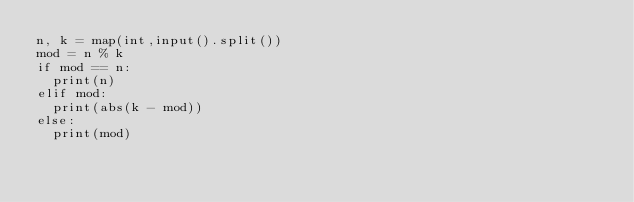Convert code to text. <code><loc_0><loc_0><loc_500><loc_500><_Python_>n, k = map(int,input().split())
mod = n % k
if mod == n:
  print(n)
elif mod:
  print(abs(k - mod))
else:
  print(mod)</code> 